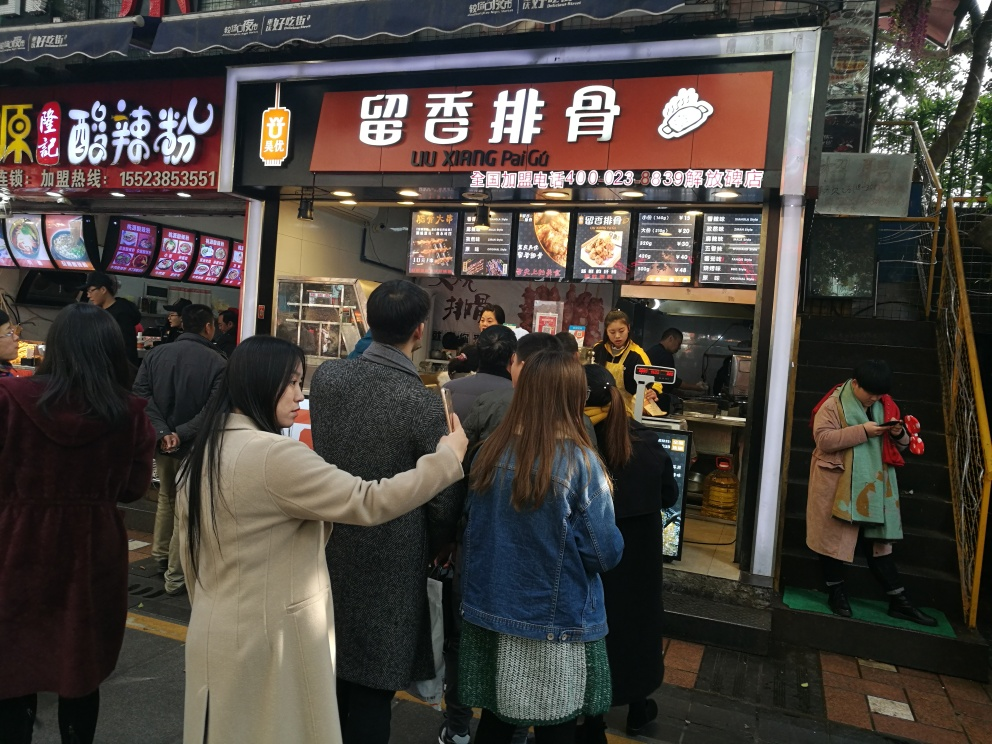Is the image quality good?
A. Yes
B. No
Answer with the option's letter from the given choices directly. Yes, the image quality is good. The details in the scene are clear, and the text on the shop signs is readable, demonstrating good resolution and adequate lighting. The sharpness of the image allows us to observe various aspects of the busy street scene distinctly. 